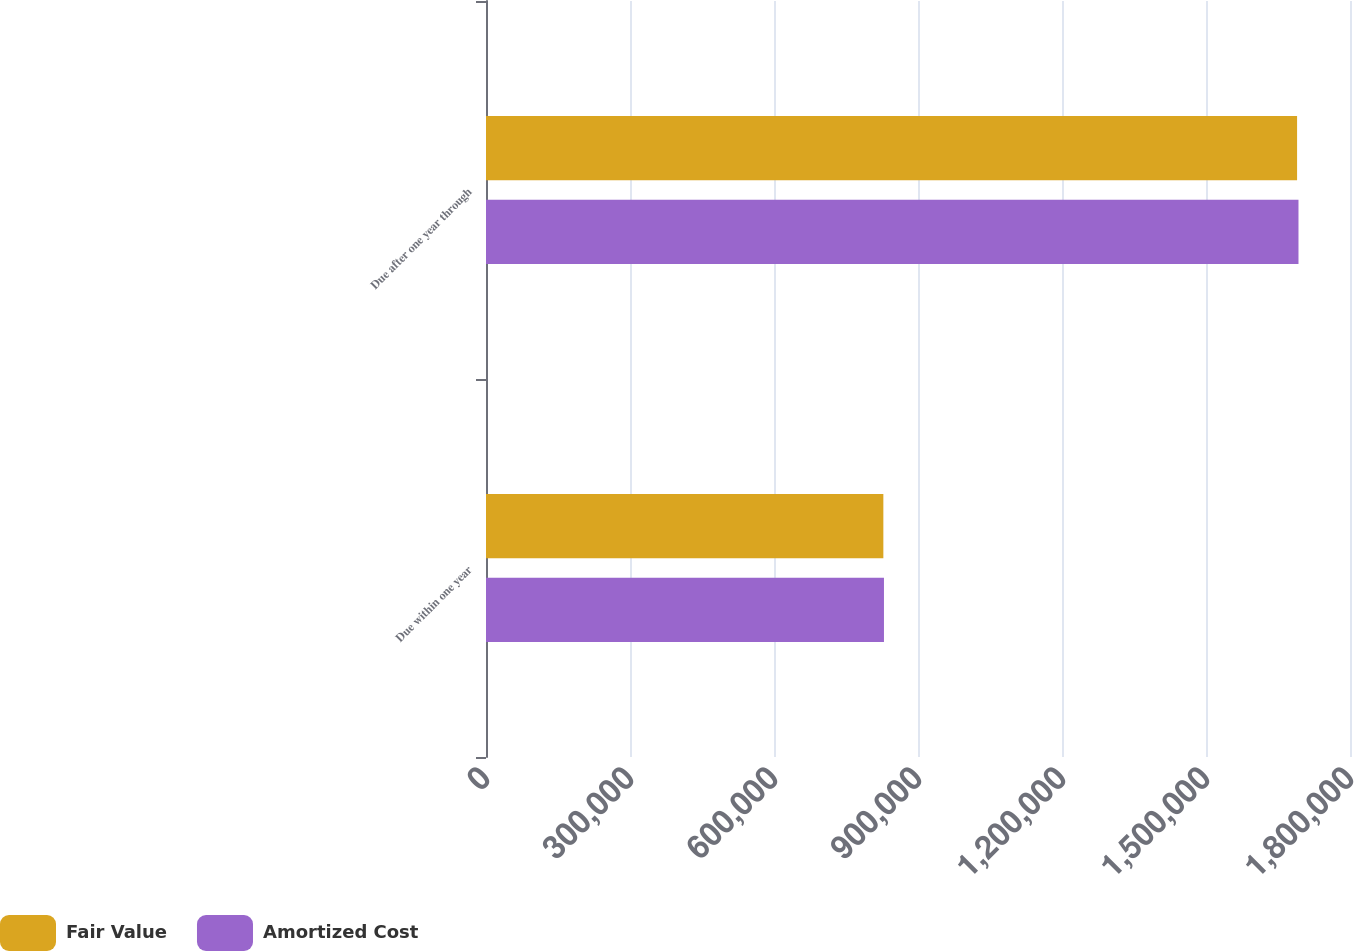Convert chart. <chart><loc_0><loc_0><loc_500><loc_500><stacked_bar_chart><ecel><fcel>Due within one year<fcel>Due after one year through<nl><fcel>Fair Value<fcel>827823<fcel>1.68975e+06<nl><fcel>Amortized Cost<fcel>829098<fcel>1.69268e+06<nl></chart> 